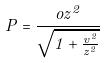Convert formula to latex. <formula><loc_0><loc_0><loc_500><loc_500>P = \frac { o z ^ { 2 } } { \sqrt { 1 + \frac { v ^ { 2 } } { z ^ { 2 } } } }</formula> 